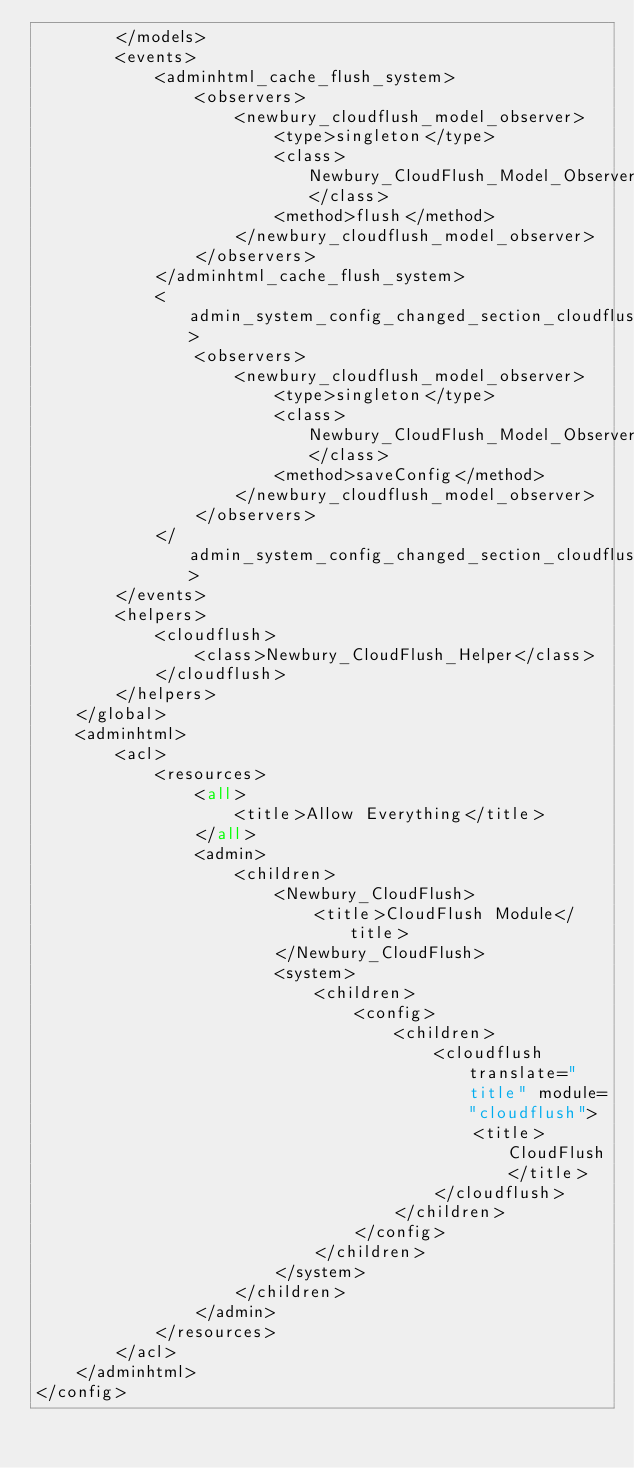Convert code to text. <code><loc_0><loc_0><loc_500><loc_500><_XML_>        </models>
        <events>
            <adminhtml_cache_flush_system>
                <observers>
                    <newbury_cloudflush_model_observer>
                        <type>singleton</type>
                        <class>Newbury_CloudFlush_Model_Observer</class>
                        <method>flush</method>
                    </newbury_cloudflush_model_observer>
                </observers>
            </adminhtml_cache_flush_system>
            <admin_system_config_changed_section_cloudflush>
                <observers>
                    <newbury_cloudflush_model_observer>
                        <type>singleton</type>
                        <class>Newbury_CloudFlush_Model_Observer</class>
                        <method>saveConfig</method>
                    </newbury_cloudflush_model_observer>
                </observers>
            </admin_system_config_changed_section_cloudflush>
        </events>
        <helpers>
            <cloudflush>
                <class>Newbury_CloudFlush_Helper</class>
            </cloudflush>
        </helpers>
    </global>
    <adminhtml>
        <acl>
            <resources>
                <all>
                    <title>Allow Everything</title>
                </all>
                <admin>
                    <children>
                        <Newbury_CloudFlush>
                            <title>CloudFlush Module</title>
                        </Newbury_CloudFlush>
                        <system>
                            <children>
                                <config>
                                    <children>
                                        <cloudflush translate="title" module="cloudflush">
                                            <title>CloudFlush</title>
                                        </cloudflush>
                                    </children>
                                </config>
                            </children>
                        </system>
                    </children>
                </admin>
            </resources>
        </acl>
    </adminhtml>
</config>
</code> 